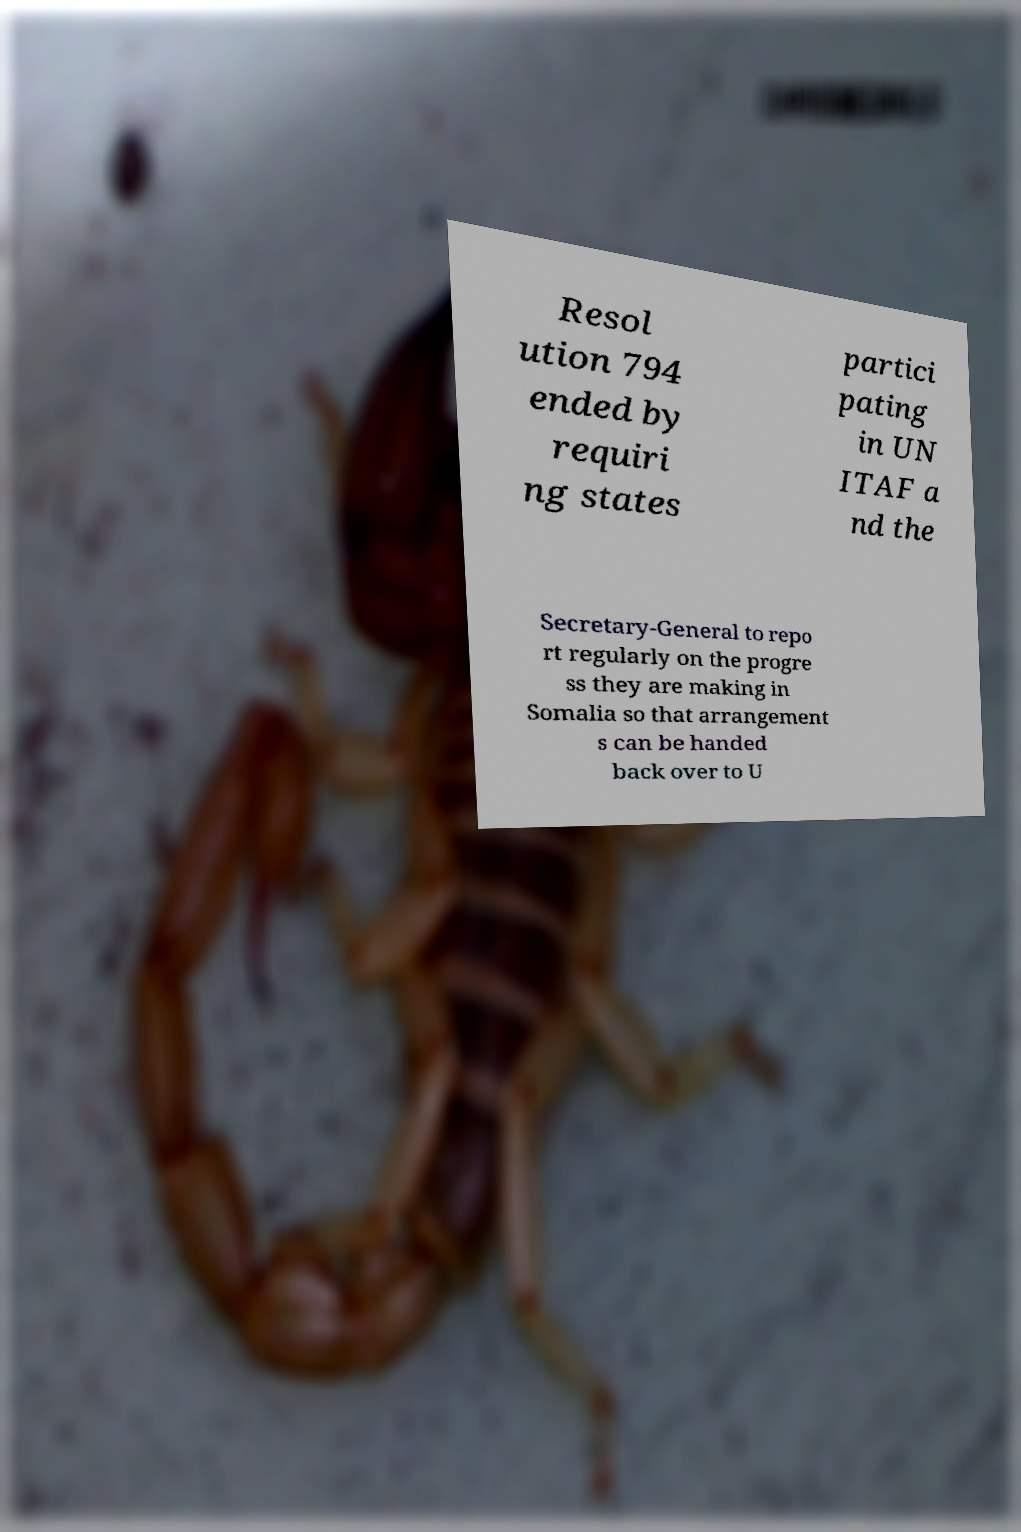Please read and relay the text visible in this image. What does it say? Resol ution 794 ended by requiri ng states partici pating in UN ITAF a nd the Secretary-General to repo rt regularly on the progre ss they are making in Somalia so that arrangement s can be handed back over to U 